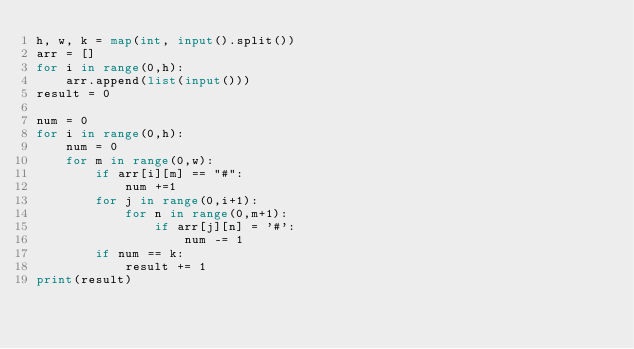Convert code to text. <code><loc_0><loc_0><loc_500><loc_500><_Python_>h, w, k = map(int, input().split())
arr = []
for i in range(0,h):
    arr.append(list(input()))
result = 0

num = 0
for i in range(0,h):
    num = 0
    for m in range(0,w):
        if arr[i][m] == "#":
            num +=1
        for j in range(0,i+1):
            for n in range(0,m+1):
                if arr[j][n] = '#':
                    num -= 1
        if num == k:
            result += 1
print(result)</code> 